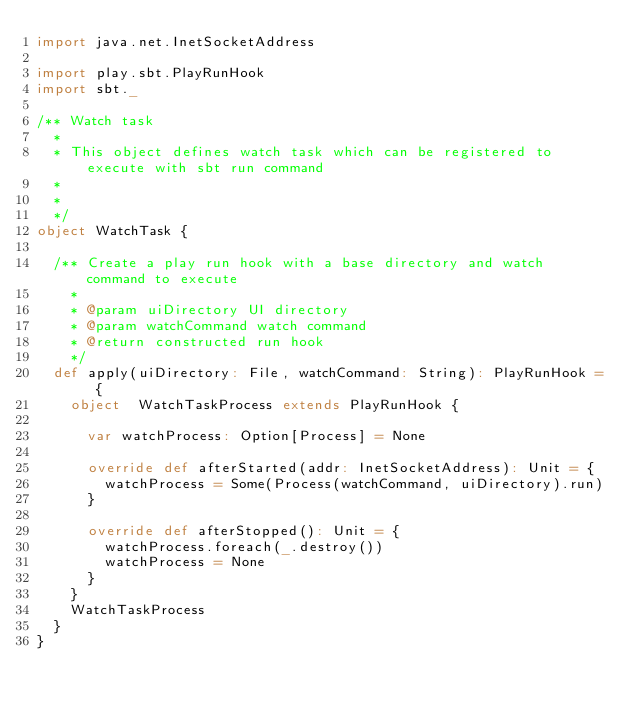<code> <loc_0><loc_0><loc_500><loc_500><_Scala_>import java.net.InetSocketAddress

import play.sbt.PlayRunHook
import sbt._

/** Watch task
  *
  * This object defines watch task which can be registered to execute with sbt run command
  *
  *
  */
object WatchTask {

  /** Create a play run hook with a base directory and watch command to execute
    *
    * @param uiDirectory UI directory
    * @param watchCommand watch command
    * @return constructed run hook
    */
  def apply(uiDirectory: File, watchCommand: String): PlayRunHook = {
    object  WatchTaskProcess extends PlayRunHook {

      var watchProcess: Option[Process] = None

      override def afterStarted(addr: InetSocketAddress): Unit = {
        watchProcess = Some(Process(watchCommand, uiDirectory).run)
      }

      override def afterStopped(): Unit = {
        watchProcess.foreach(_.destroy())
        watchProcess = None
      }
    }
    WatchTaskProcess
  }
}

</code> 